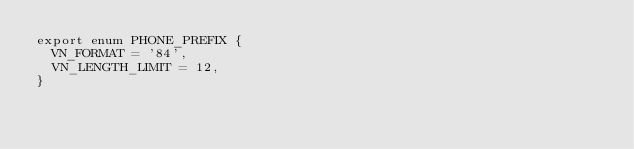<code> <loc_0><loc_0><loc_500><loc_500><_TypeScript_>export enum PHONE_PREFIX {
  VN_FORMAT = '84',
  VN_LENGTH_LIMIT = 12,
}
</code> 